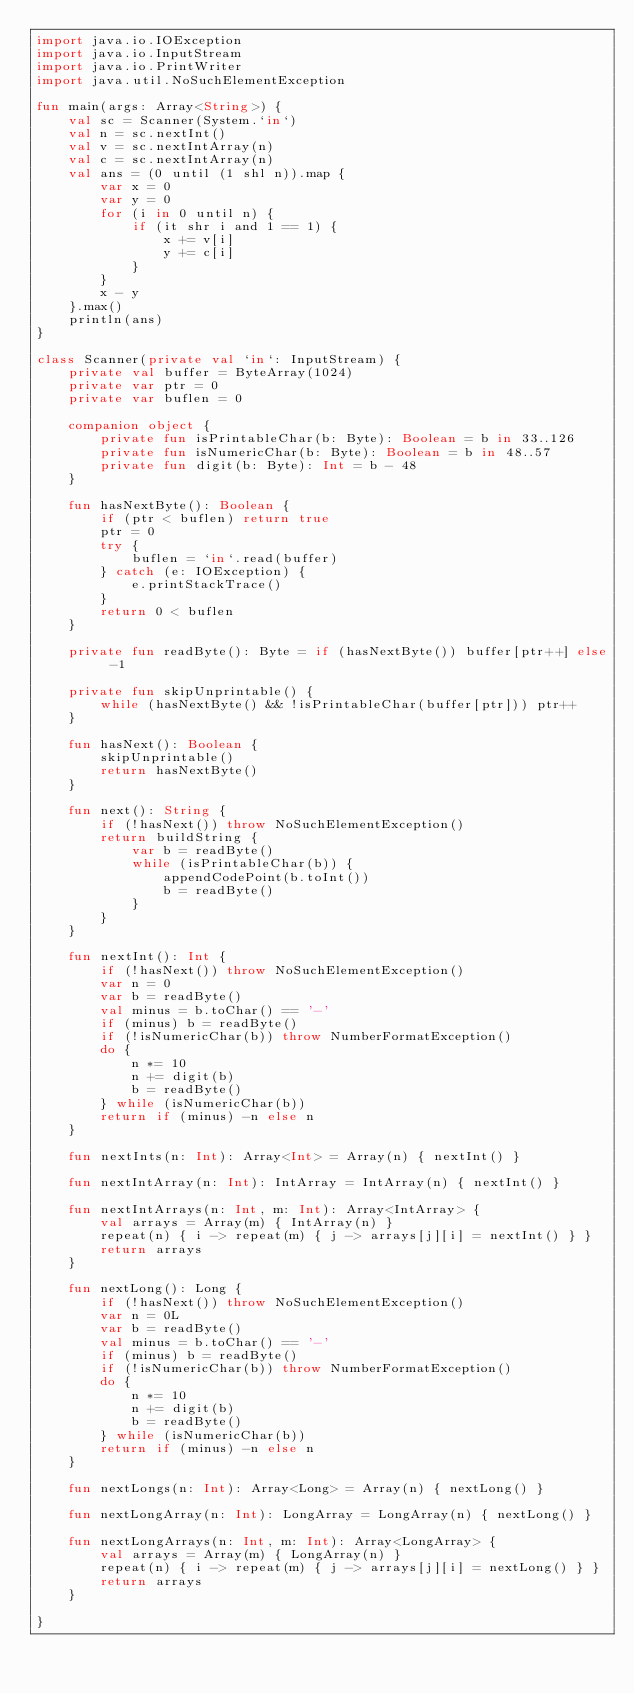Convert code to text. <code><loc_0><loc_0><loc_500><loc_500><_Kotlin_>import java.io.IOException
import java.io.InputStream
import java.io.PrintWriter
import java.util.NoSuchElementException

fun main(args: Array<String>) {
    val sc = Scanner(System.`in`)
    val n = sc.nextInt()
    val v = sc.nextIntArray(n)
    val c = sc.nextIntArray(n)
    val ans = (0 until (1 shl n)).map {
        var x = 0
        var y = 0
        for (i in 0 until n) {
            if (it shr i and 1 == 1) {
                x += v[i]
                y += c[i]
            }
        }
        x - y
    }.max()
    println(ans)
}

class Scanner(private val `in`: InputStream) {
    private val buffer = ByteArray(1024)
    private var ptr = 0
    private var buflen = 0

    companion object {
        private fun isPrintableChar(b: Byte): Boolean = b in 33..126
        private fun isNumericChar(b: Byte): Boolean = b in 48..57
        private fun digit(b: Byte): Int = b - 48
    }

    fun hasNextByte(): Boolean {
        if (ptr < buflen) return true
        ptr = 0
        try {
            buflen = `in`.read(buffer)
        } catch (e: IOException) {
            e.printStackTrace()
        }
        return 0 < buflen
    }

    private fun readByte(): Byte = if (hasNextByte()) buffer[ptr++] else -1

    private fun skipUnprintable() {
        while (hasNextByte() && !isPrintableChar(buffer[ptr])) ptr++
    }

    fun hasNext(): Boolean {
        skipUnprintable()
        return hasNextByte()
    }

    fun next(): String {
        if (!hasNext()) throw NoSuchElementException()
        return buildString {
            var b = readByte()
            while (isPrintableChar(b)) {
                appendCodePoint(b.toInt())
                b = readByte()
            }
        }
    }

    fun nextInt(): Int {
        if (!hasNext()) throw NoSuchElementException()
        var n = 0
        var b = readByte()
        val minus = b.toChar() == '-'
        if (minus) b = readByte()
        if (!isNumericChar(b)) throw NumberFormatException()
        do {
            n *= 10
            n += digit(b)
            b = readByte()
        } while (isNumericChar(b))
        return if (minus) -n else n
    }

    fun nextInts(n: Int): Array<Int> = Array(n) { nextInt() }

    fun nextIntArray(n: Int): IntArray = IntArray(n) { nextInt() }

    fun nextIntArrays(n: Int, m: Int): Array<IntArray> {
        val arrays = Array(m) { IntArray(n) }
        repeat(n) { i -> repeat(m) { j -> arrays[j][i] = nextInt() } }
        return arrays
    }

    fun nextLong(): Long {
        if (!hasNext()) throw NoSuchElementException()
        var n = 0L
        var b = readByte()
        val minus = b.toChar() == '-'
        if (minus) b = readByte()
        if (!isNumericChar(b)) throw NumberFormatException()
        do {
            n *= 10
            n += digit(b)
            b = readByte()
        } while (isNumericChar(b))
        return if (minus) -n else n
    }

    fun nextLongs(n: Int): Array<Long> = Array(n) { nextLong() }

    fun nextLongArray(n: Int): LongArray = LongArray(n) { nextLong() }

    fun nextLongArrays(n: Int, m: Int): Array<LongArray> {
        val arrays = Array(m) { LongArray(n) }
        repeat(n) { i -> repeat(m) { j -> arrays[j][i] = nextLong() } }
        return arrays
    }

}</code> 